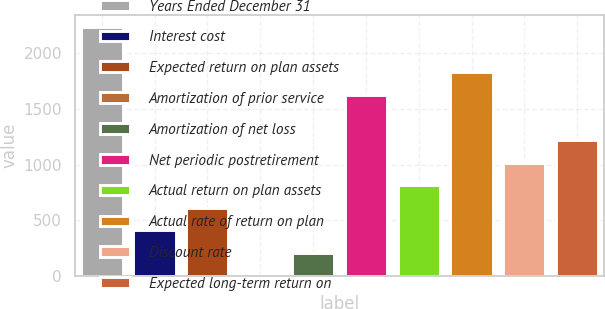Convert chart to OTSL. <chart><loc_0><loc_0><loc_500><loc_500><bar_chart><fcel>Years Ended December 31<fcel>Interest cost<fcel>Expected return on plan assets<fcel>Amortization of prior service<fcel>Amortization of net loss<fcel>Net periodic postretirement<fcel>Actual return on plan assets<fcel>Actual rate of return on plan<fcel>Discount rate<fcel>Expected long-term return on<nl><fcel>2235.1<fcel>407.2<fcel>610.3<fcel>1<fcel>204.1<fcel>1625.8<fcel>813.4<fcel>1828.9<fcel>1016.5<fcel>1219.6<nl></chart> 